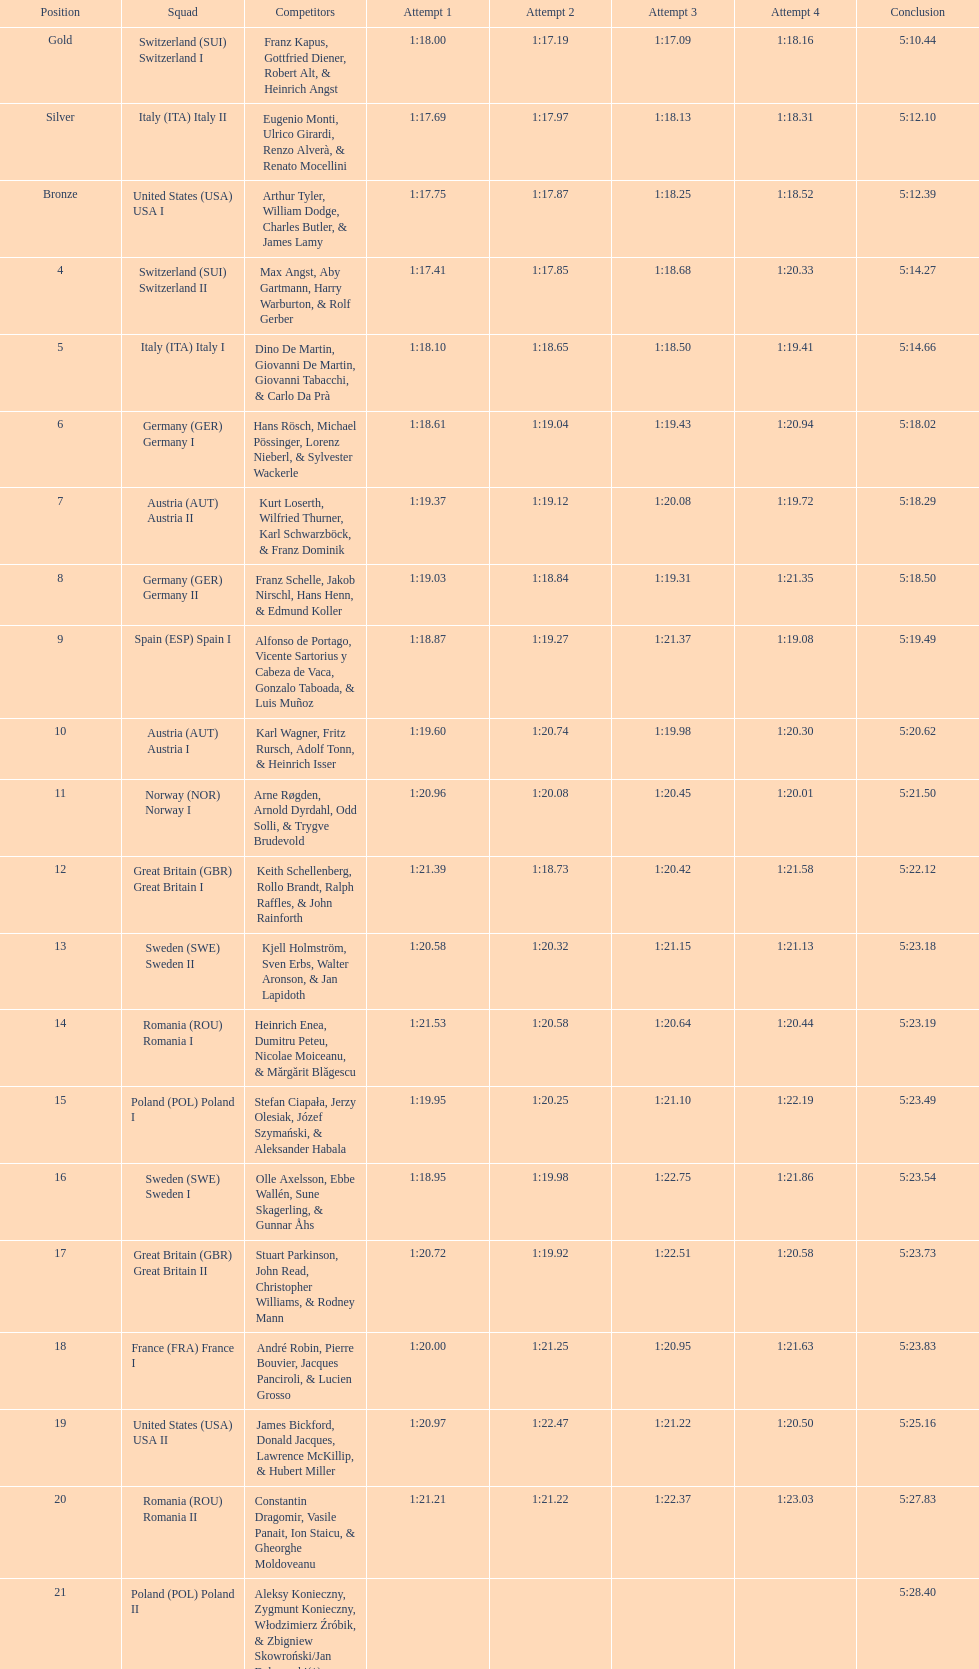Which team won the most runs? Switzerland. 